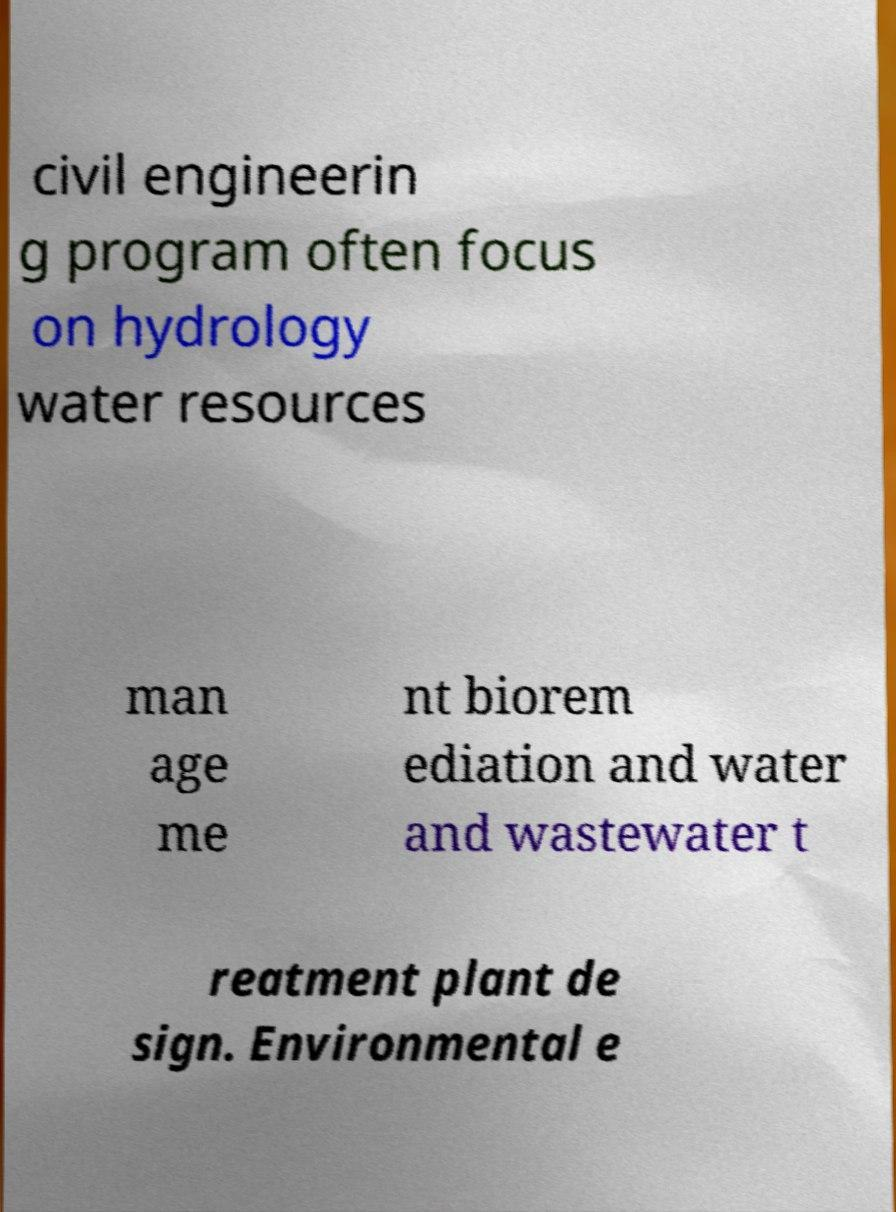For documentation purposes, I need the text within this image transcribed. Could you provide that? civil engineerin g program often focus on hydrology water resources man age me nt biorem ediation and water and wastewater t reatment plant de sign. Environmental e 